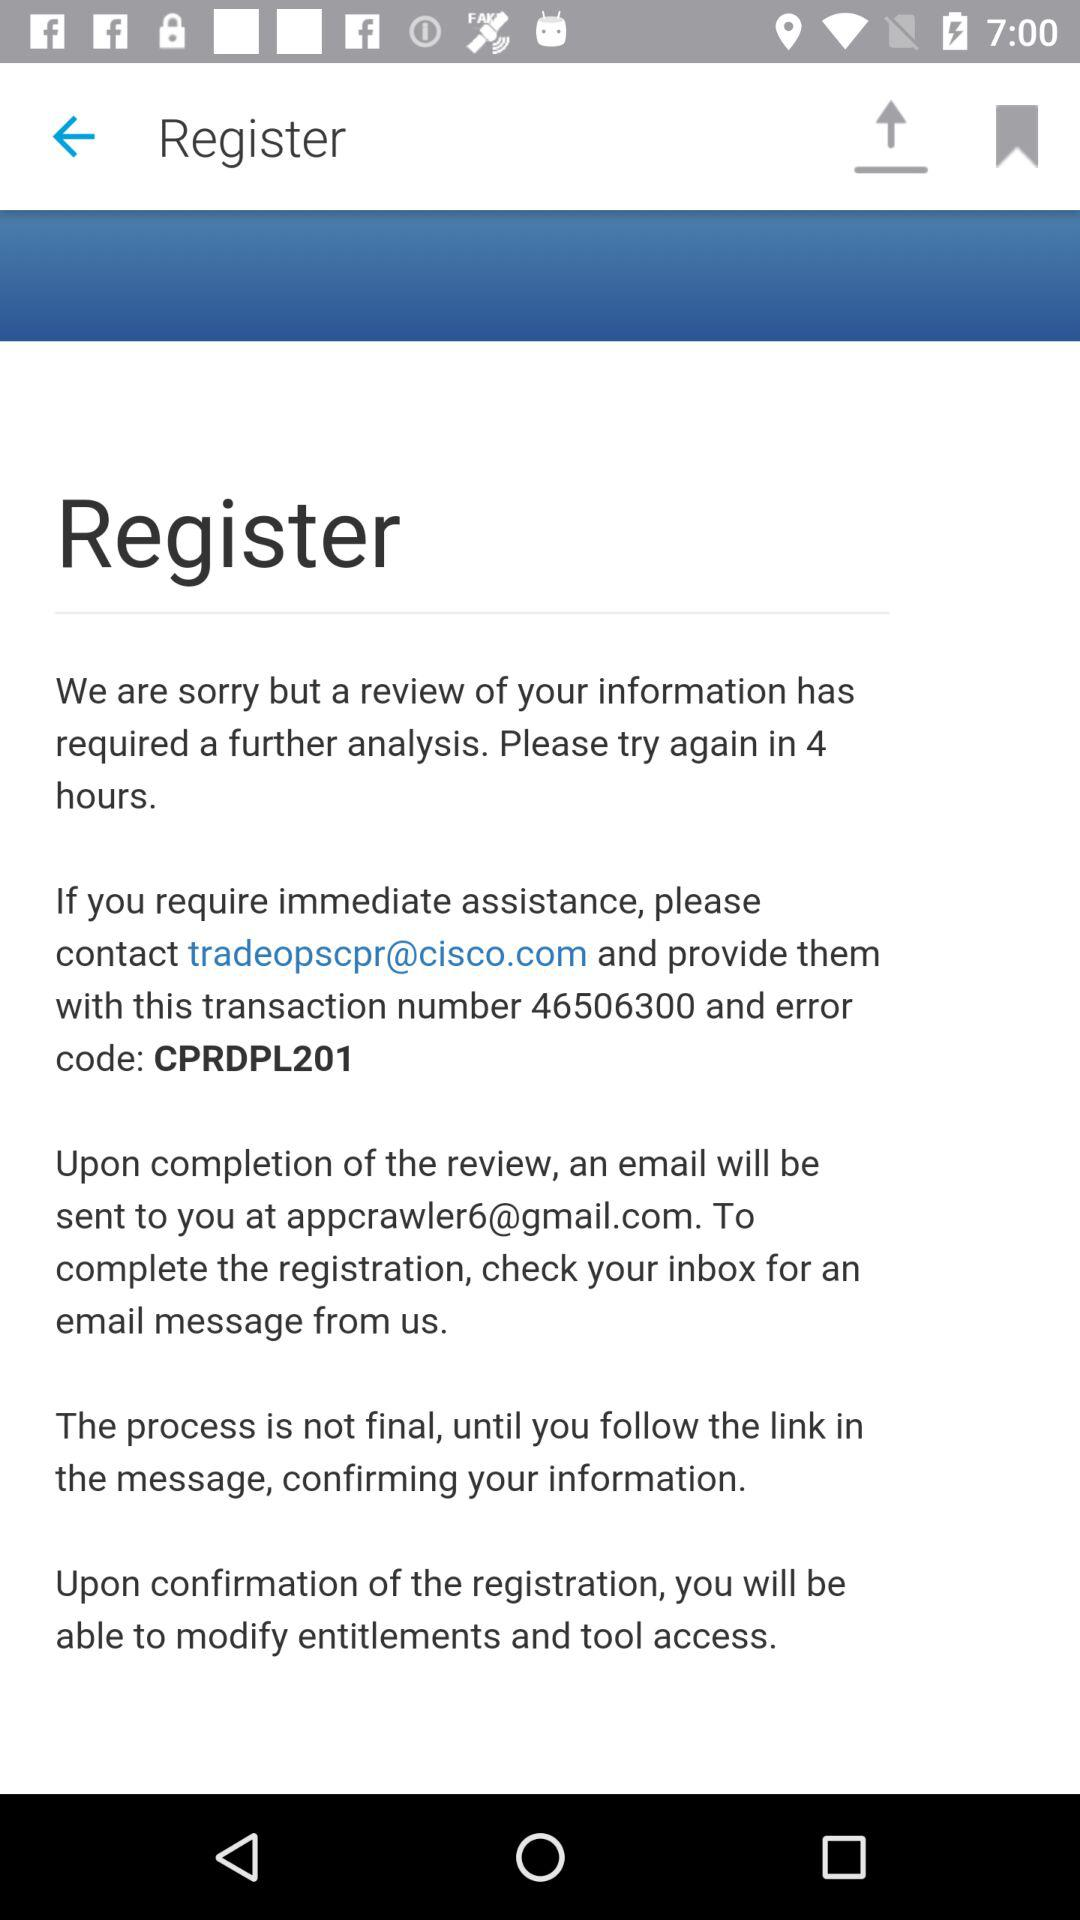At which email address will I get the email after the completion of the review? You will get an email at appcrawler6@gmail.com after the completion of the review. 